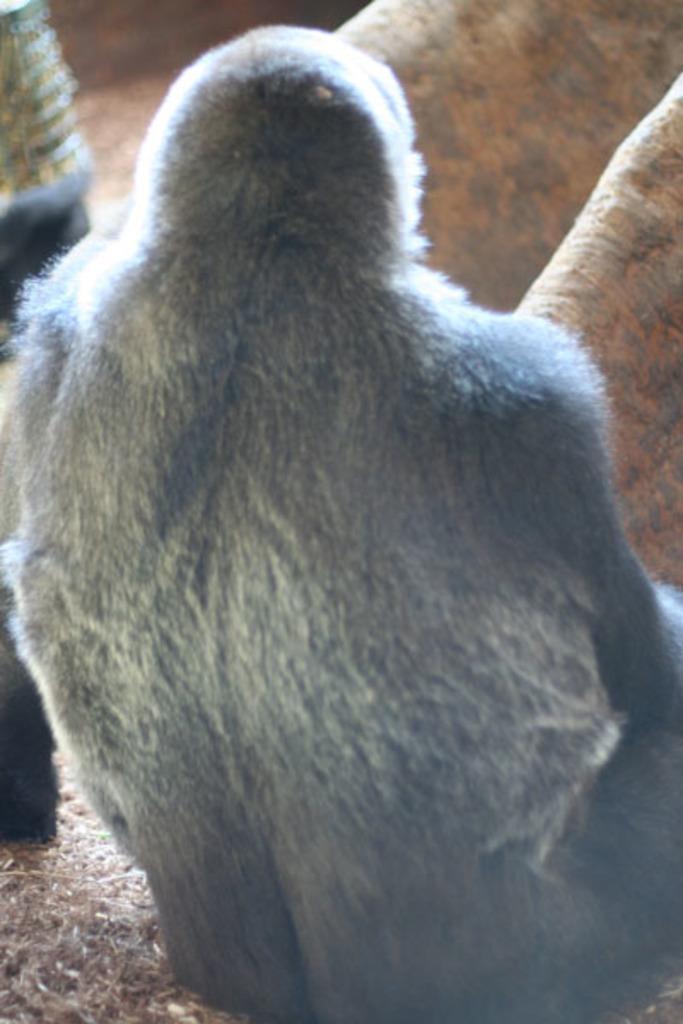In one or two sentences, can you explain what this image depicts? In this image we can see a chimpanzee on the ground, also there are some other animals, around it. 